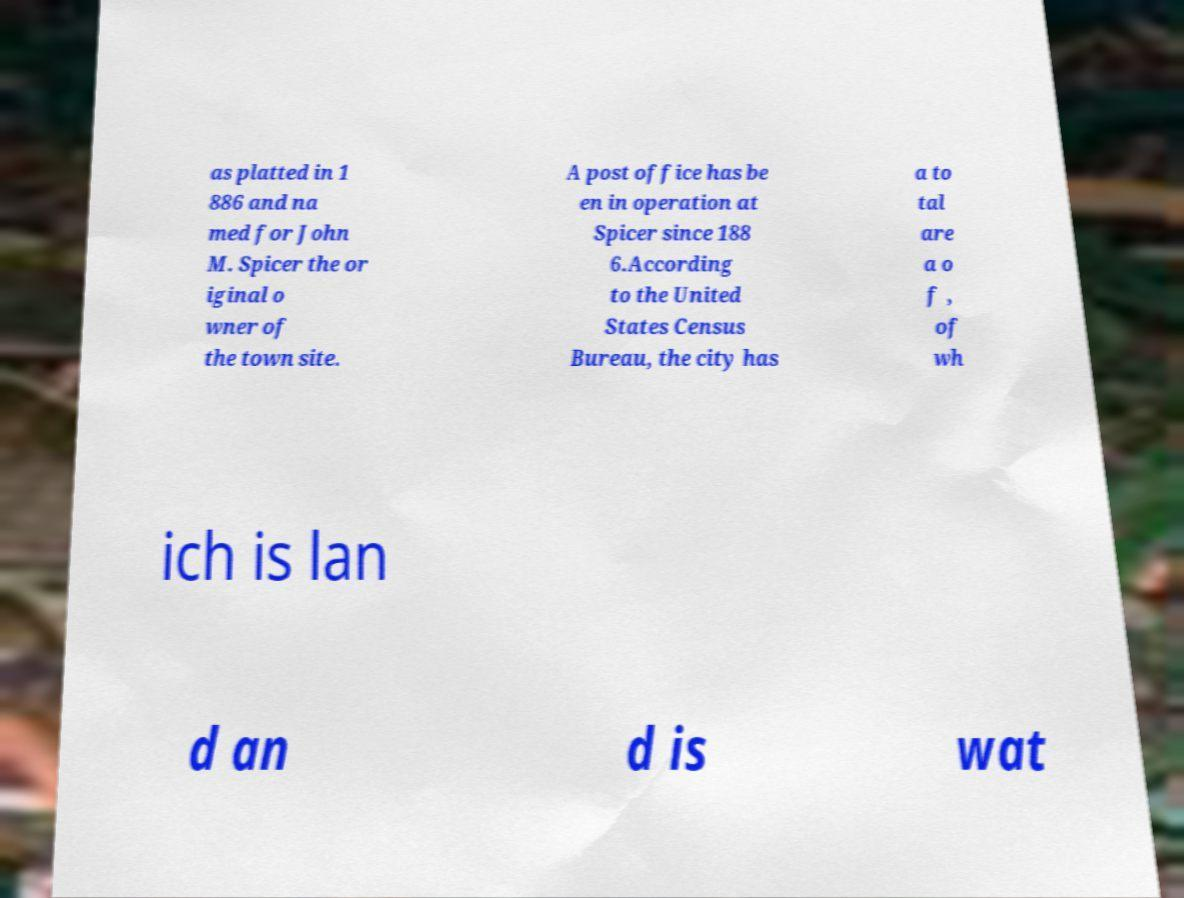Can you read and provide the text displayed in the image?This photo seems to have some interesting text. Can you extract and type it out for me? as platted in 1 886 and na med for John M. Spicer the or iginal o wner of the town site. A post office has be en in operation at Spicer since 188 6.According to the United States Census Bureau, the city has a to tal are a o f , of wh ich is lan d an d is wat 